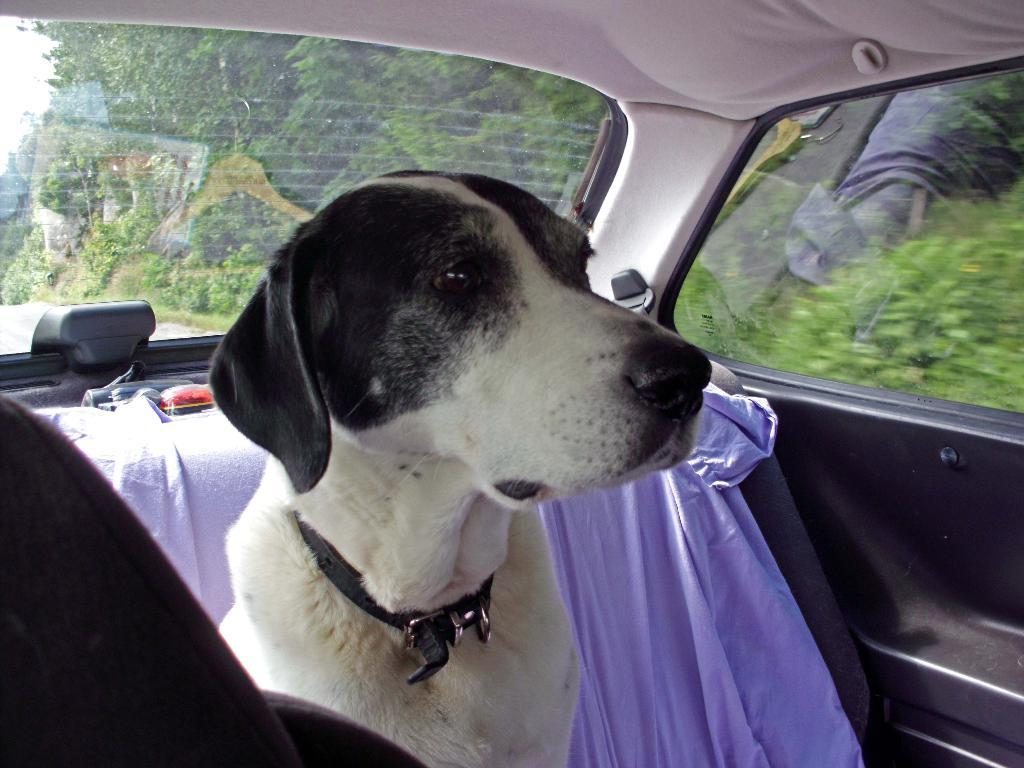What animal is present in the image? There is a dog in the image. Where is the dog located? The dog is sitting inside a car. What can be seen through the car's windows? Trees are visible through the car's windows. What type of leather material is the dog chewing on in the image? There is no leather material present in the image; the dog is sitting inside a car. What tin object is the dog playing with in the image? There is no tin object present in the image; the dog is simply sitting inside the car. 